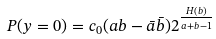<formula> <loc_0><loc_0><loc_500><loc_500>P ( y = 0 ) & = c _ { 0 } ( a b - \bar { a } \bar { b } ) 2 ^ { \frac { H ( b ) } { a + b - 1 } }</formula> 